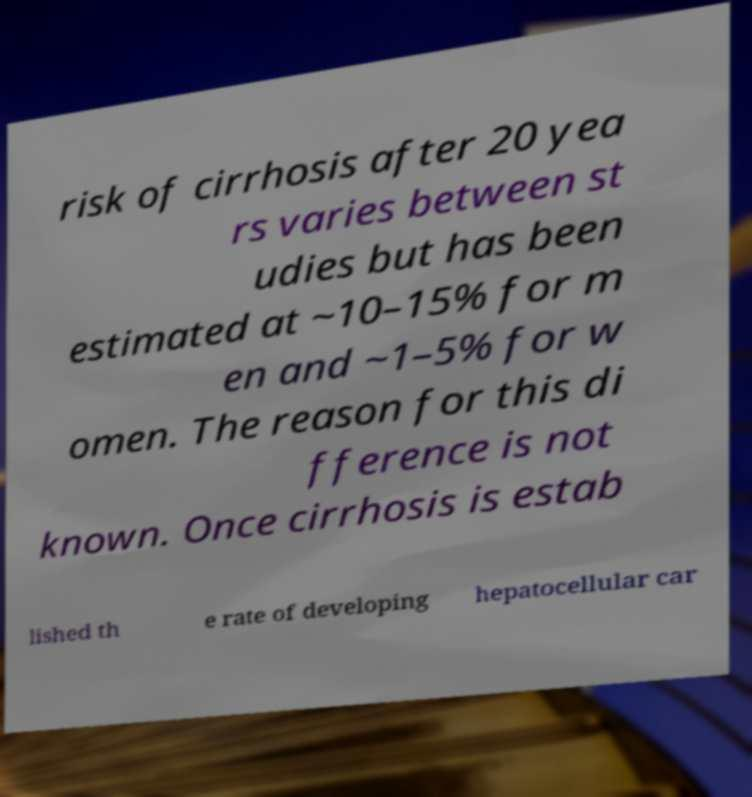Can you read and provide the text displayed in the image?This photo seems to have some interesting text. Can you extract and type it out for me? risk of cirrhosis after 20 yea rs varies between st udies but has been estimated at ~10–15% for m en and ~1–5% for w omen. The reason for this di fference is not known. Once cirrhosis is estab lished th e rate of developing hepatocellular car 